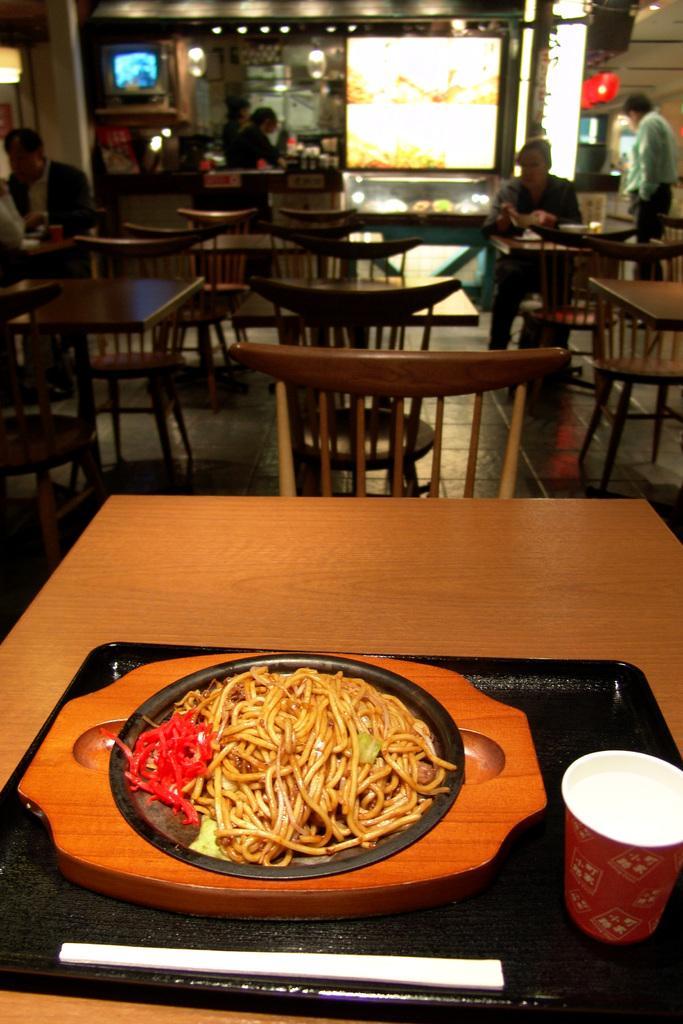Could you give a brief overview of what you see in this image? In this image there is a table and we can see a tray, chopsticks, noodles, glass and a plate placed on the table. In the background there are chairs and tables. We can see people sitting. There is a store and we can see a screen. On the right there is a man standing. 